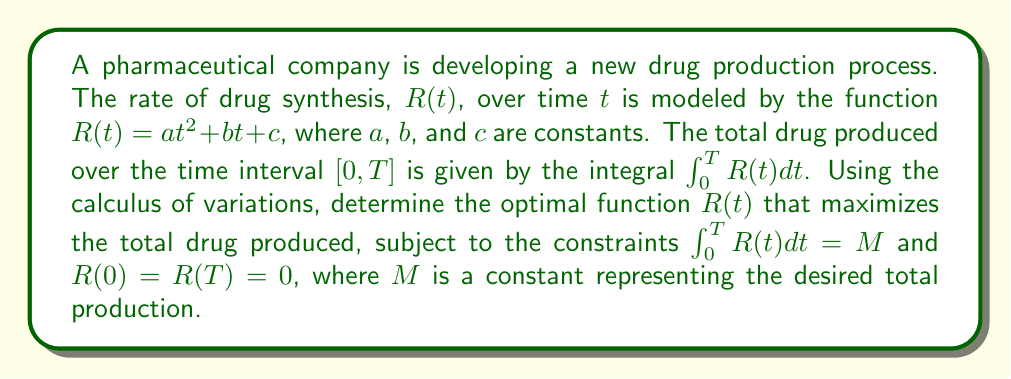Can you answer this question? To solve this problem, we'll use the Euler-Lagrange equation from the calculus of variations:

1) The functional to be maximized is:
   $$J[R] = \int_0^T R(t) dt$$

2) We have the isoperimetric constraint:
   $$\int_0^T R(t) dt = M$$

3) Form the augmented functional with Lagrange multiplier $\lambda$:
   $$F[R] = \int_0^T [R(t) + \lambda R(t)] dt = \int_0^T (1 + \lambda)R(t) dt$$

4) The Euler-Lagrange equation is:
   $$\frac{\partial}{\partial R}\left[(1 + \lambda)R\right] - \frac{d}{dt}\left(\frac{\partial}{\partial R'}\left[(1 + \lambda)R\right]\right) = 0$$

5) Simplifying:
   $$(1 + \lambda) - 0 = 0$$
   $$(1 + \lambda) = 0$$
   $$\lambda = -1$$

6) This result implies that the optimal $R(t)$ is a constant function, except at the endpoints where it must satisfy the boundary conditions.

7) Given the form $R(t) = at^2 + bt + c$ and the constraints $R(0) = R(T) = 0$, we can determine:
   $$c = 0$$
   $$aT^2 + bT = 0$$

8) Using the isoperimetric constraint:
   $$\int_0^T (at^2 + bt) dt = M$$
   $$\frac{1}{3}aT^3 + \frac{1}{2}bT^2 = M$$

9) Solving the system of equations from steps 7 and 8:
   $$a = \frac{6M}{T^3}$$
   $$b = -\frac{6M}{T^2}$$

Therefore, the optimal function $R(t)$ is:
$$R(t) = \frac{6M}{T^3}t^2 - \frac{6M}{T^2}t$$
Answer: $R(t) = \frac{6M}{T^3}t^2 - \frac{6M}{T^2}t$ 